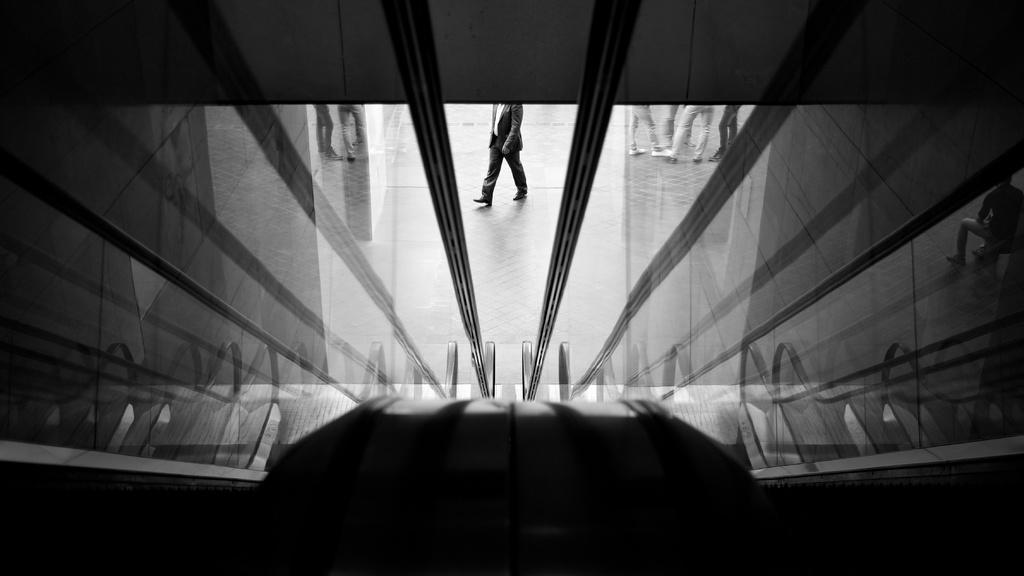What type of wall is present in the image? There is a glass wall in the image. Can you describe what is happening on the other side of the glass wall? A person is visible through the glass wall, walking in the center. What is the person wearing? The person is wearing a suit. Are there any other people visible in the image? Yes, there are other people standing on the right side of the image. What type of water is being approved by the unit in the image? There is no water or unit present in the image; it features a glass wall with a person walking in the center and other people standing on the right side. 